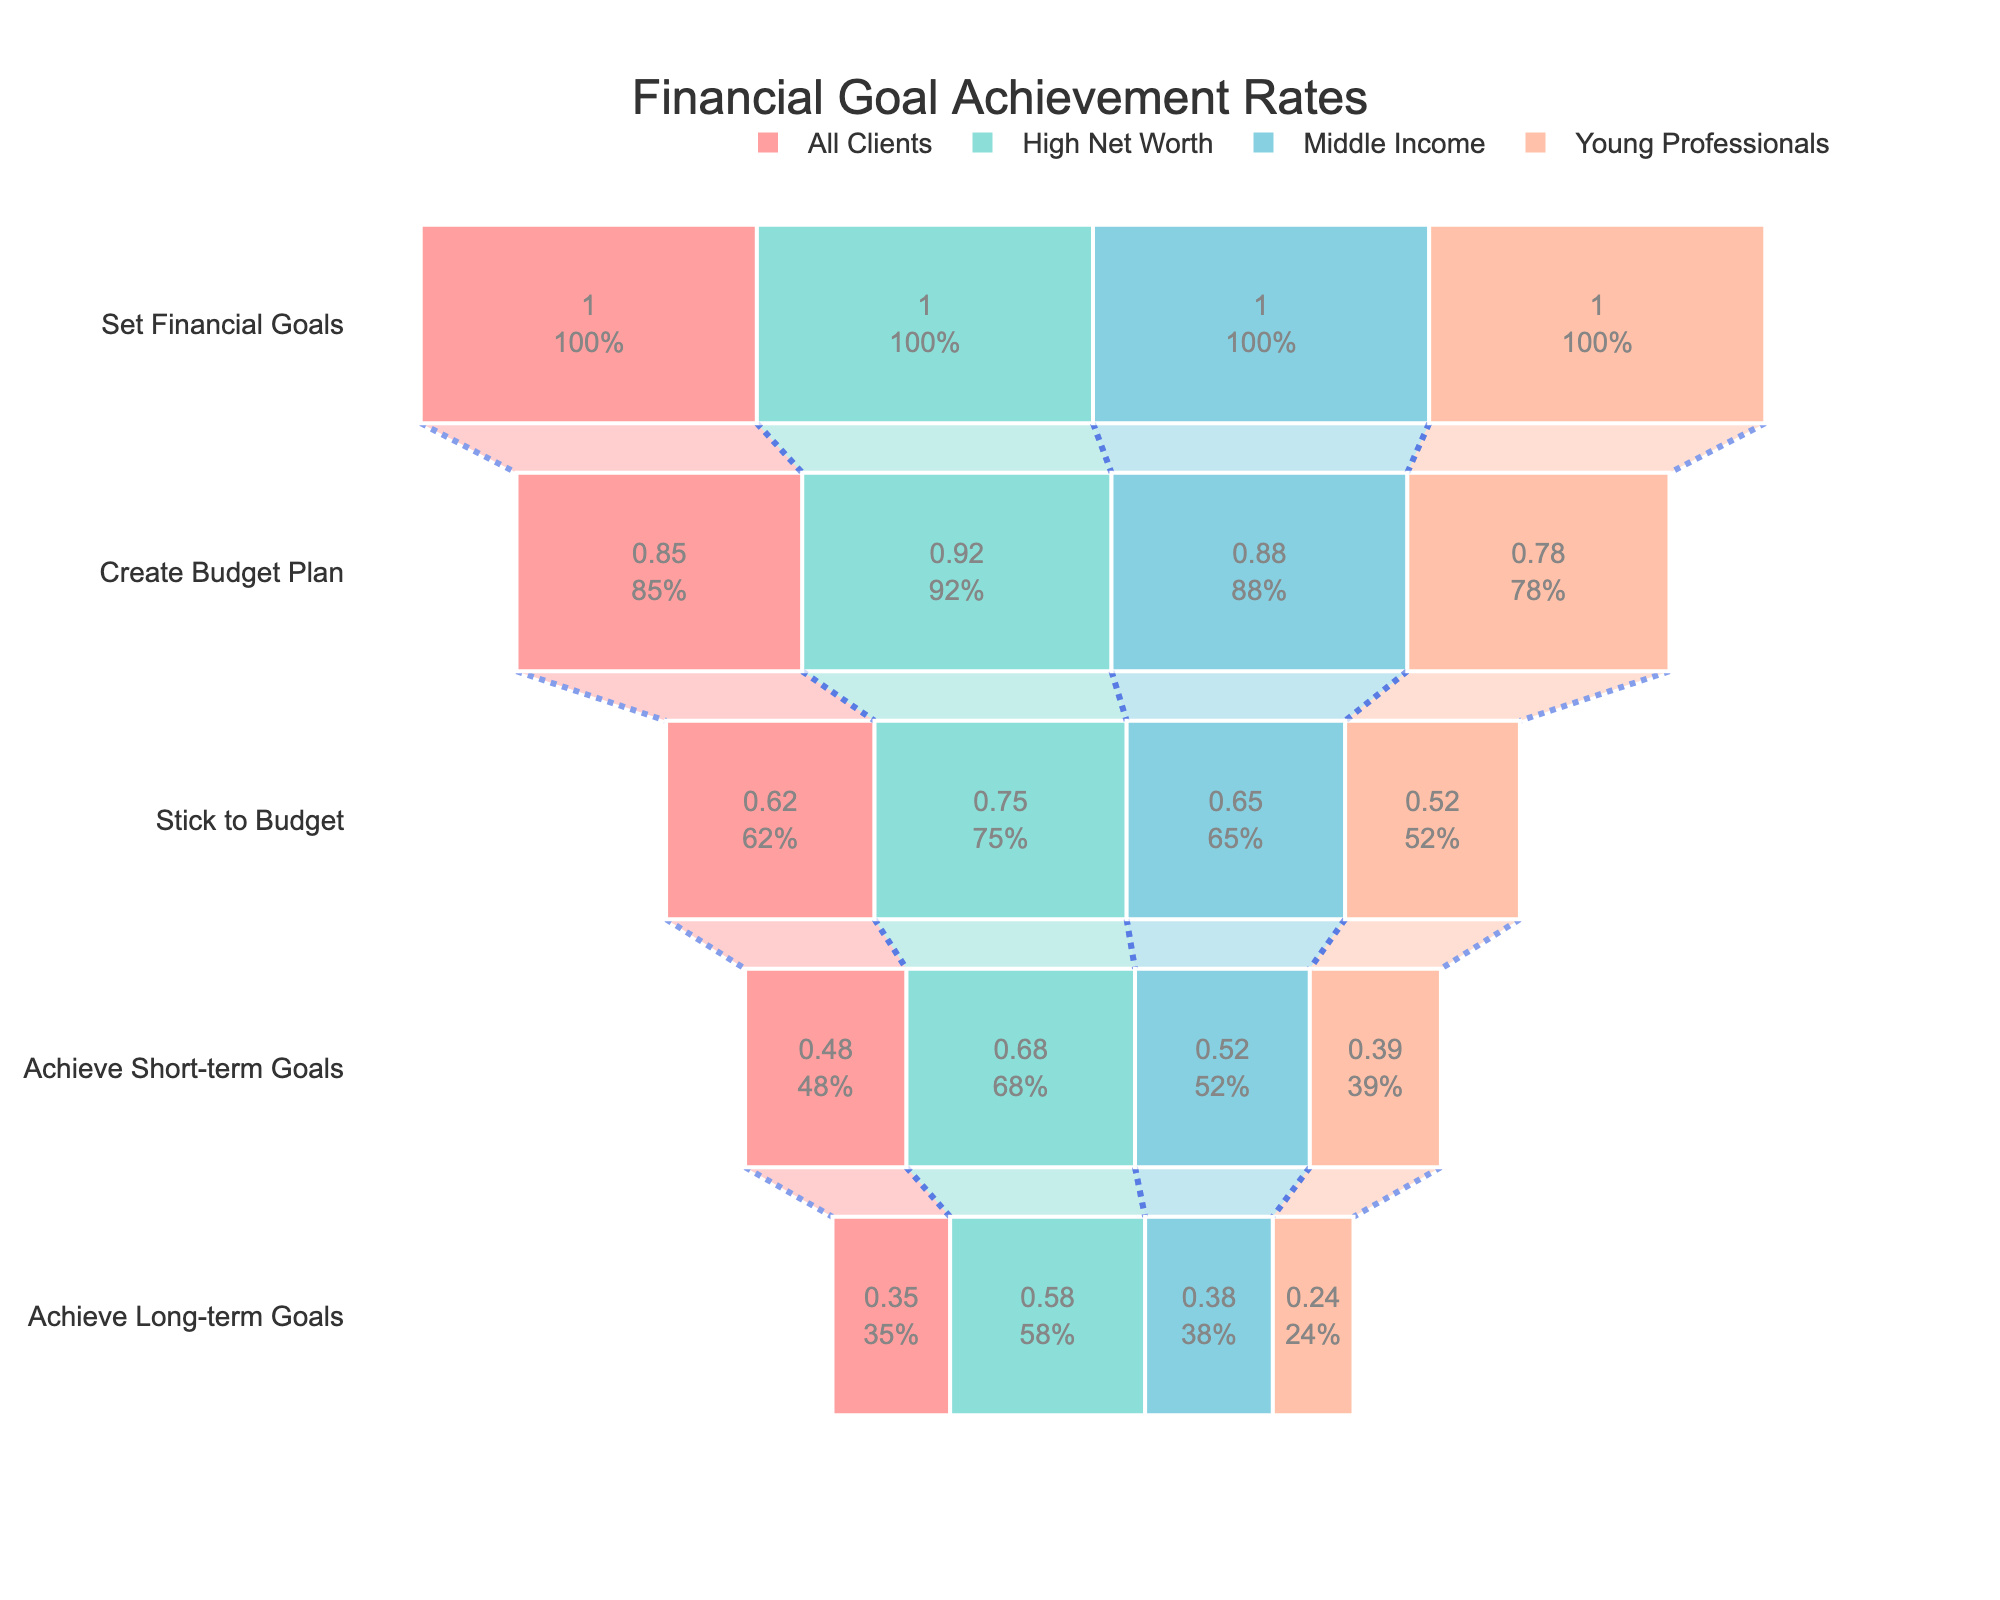What is the funnel chart's title? The funnel chart's title is written at the top of the figure, and it’s typically in a larger and bold font compared to other text in the chart.
Answer: Financial Goal Achievement Rates Which client segment has the highest percentage for achieving long-term goals? To determine this, look at the final stage, "Achieve Long-term Goals," and compare the percentages for each client segment.
Answer: High Net Worth What is the difference in percentage between High Net Worth and Young Professionals in the "Stick to Budget" stage? First, identify the percentages for both groups from the "Stick to Budget" stage. High Net Worth is at 75%, and Young Professionals are at 52%. Subtract 52% from 75%: 75% - 52% = 23%.
Answer: 23% How many stages are represented in the funnel chart? Count the distinct stages listed along the y-axis of the funnel chart.
Answer: 5 Which client segment shows the least percentage drop from "Create Budget Plan" to "Stick to Budget"? Calculate the percentage drop for each client segment by subtracting the percentage of "Stick to Budget" from "Create Budget Plan." The smallest percentage drop indicates the least drop. 
- High Net Worth: 92% - 75% = 17%
- Middle Income: 88% - 65% = 23%
- Young Professionals: 78% - 52% = 26%
The least drop is for High Net Worth.
Answer: High Net Worth By how much does the percentage for achieving short-term goals of Middle Income clients exceed that of Young Professionals? Compare the percentages for "Achieve Short-term Goals." For Middle Income, it's 52%, and for Young Professionals, it's 39%. Subtract the percentage of Young Professionals from Middle Income: 52% - 39% = 13%.
Answer: 13% Which stage shows the largest drop in achievement rates across all client segments combined? Calculate the percentage drop for each stage transition by averaging the rates for all segments. Compare these drops and identify the largest.
- Set Financial Goals to Create Budget Plan: (1 - 0.85+0.92+0.88+0.78)/4 = 0.82%
- Create Budget Plan to Stick to Budget: (0.85+0.92+0.88+0.78 - 0.62+0.75+0.65+0.52)/4 = 0.77%
- Stick to Budget to Achieve Short-term Goals: (0.62+0.75+0.65+0.52 - 0.48+0.68+0.52+0.39)/4 = 0.56%
- Achieve Short-term Goals to Achieve Long-term Goals: (0.48+0.68+0.52+0.39 - 0.35+0.58+0.38+0.24)/4 = 0.58%
The largest drop is from "Set Financial Goals" to "Create Budget Plan".
Answer: Set Financial Goals to Create Budget Plan Is there any client segment where more than half of the clients achieve long-term goals? Look at the percentages in "Achieve Long-term Goals" for each client segment and check if any are above 50%. High Net Worth is at 58%, which is greater than 50%.
Answer: Yes, High Net Worth Which stage has the largest difference between the highest and lowest achieving client segments? For each stage, calculate the difference between the highest and lowest values.
- Set Financial Goals: 100% - 100% = 0%
- Create Budget Plan: 92% - 78% = 14%
- Stick to Budget: 75% - 52% = 23%
- Achieve Short-term Goals: 68% - 39% = 29%
- Achieve Long-term Goals: 58% - 24% = 34%
The largest difference is in "Achieve Long-term Goals" with 34%.
Answer: Achieve Long-term Goals 